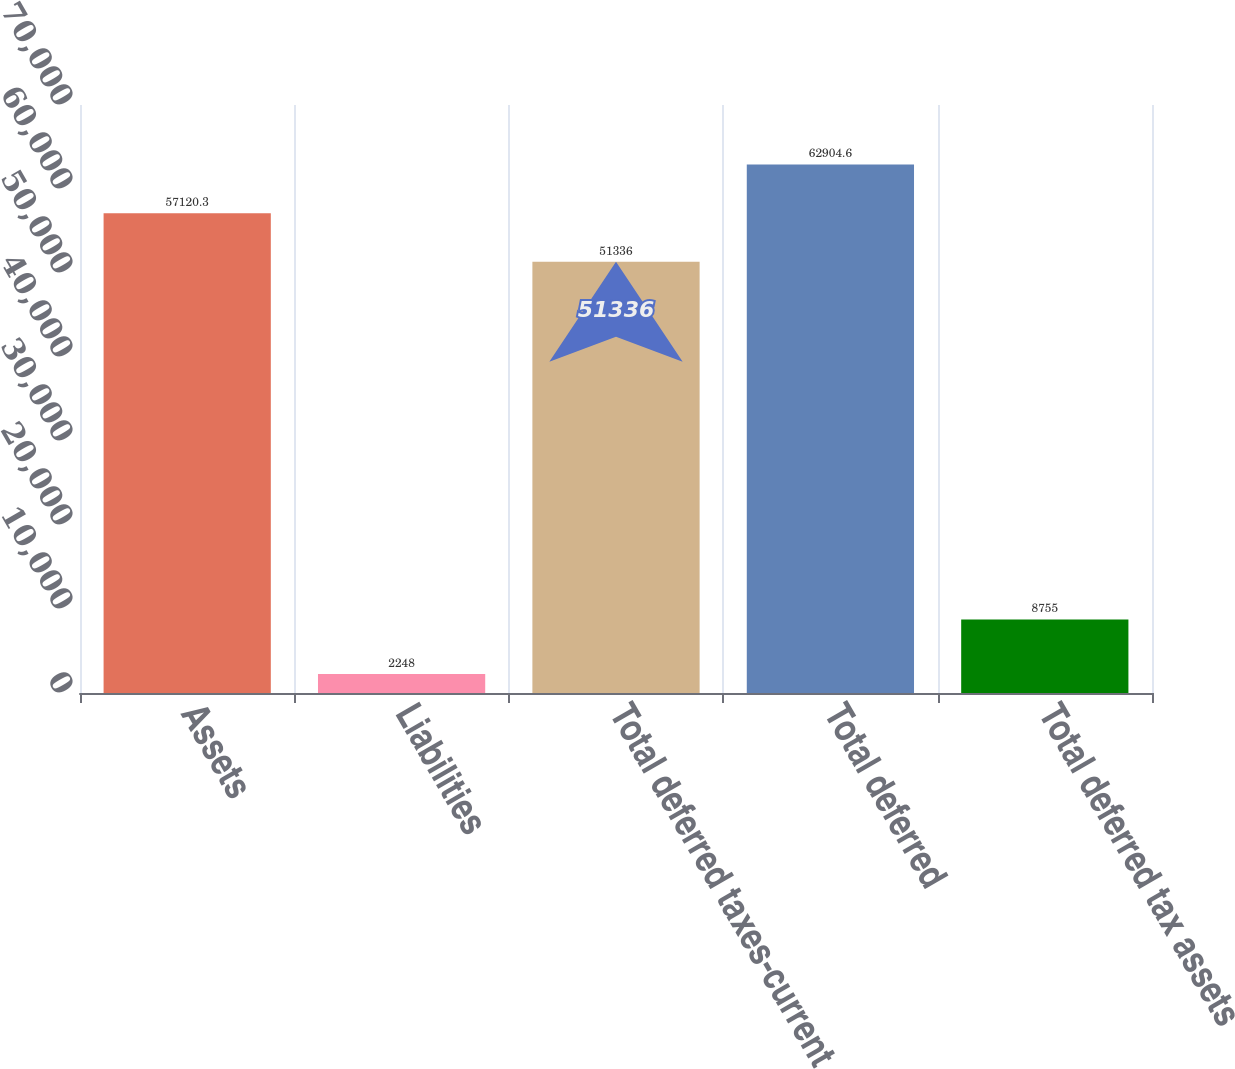Convert chart to OTSL. <chart><loc_0><loc_0><loc_500><loc_500><bar_chart><fcel>Assets<fcel>Liabilities<fcel>Total deferred taxes-current<fcel>Total deferred<fcel>Total deferred tax assets<nl><fcel>57120.3<fcel>2248<fcel>51336<fcel>62904.6<fcel>8755<nl></chart> 